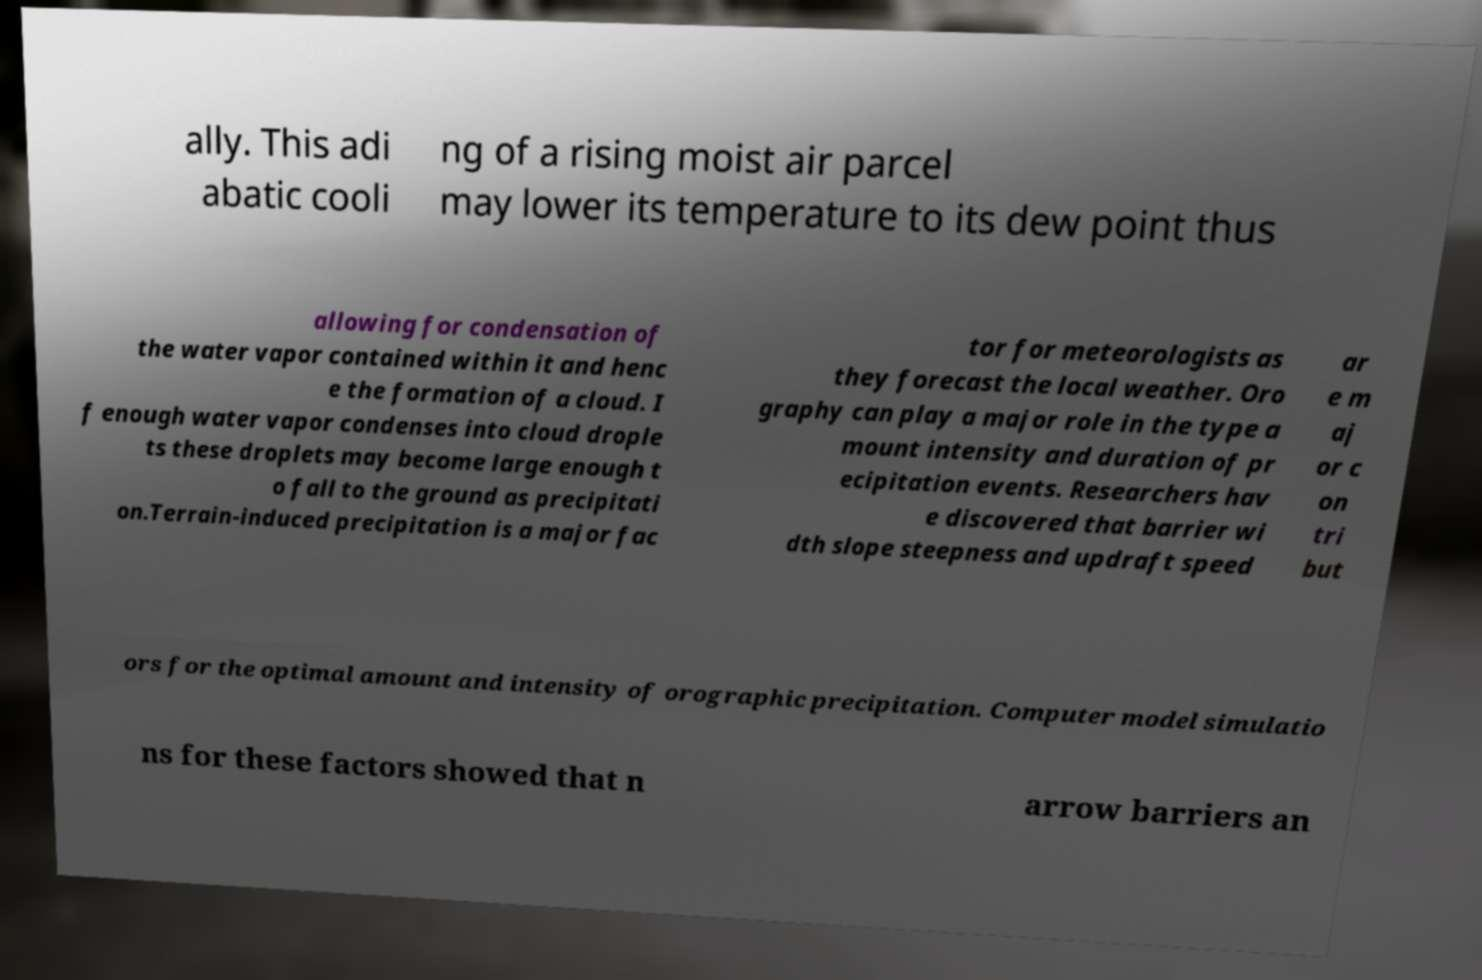Can you read and provide the text displayed in the image?This photo seems to have some interesting text. Can you extract and type it out for me? ally. This adi abatic cooli ng of a rising moist air parcel may lower its temperature to its dew point thus allowing for condensation of the water vapor contained within it and henc e the formation of a cloud. I f enough water vapor condenses into cloud drople ts these droplets may become large enough t o fall to the ground as precipitati on.Terrain-induced precipitation is a major fac tor for meteorologists as they forecast the local weather. Oro graphy can play a major role in the type a mount intensity and duration of pr ecipitation events. Researchers hav e discovered that barrier wi dth slope steepness and updraft speed ar e m aj or c on tri but ors for the optimal amount and intensity of orographic precipitation. Computer model simulatio ns for these factors showed that n arrow barriers an 